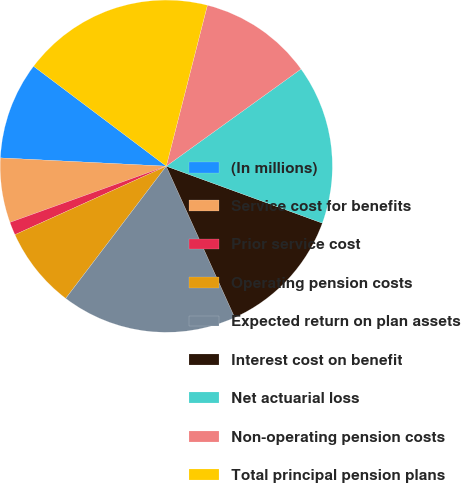Convert chart to OTSL. <chart><loc_0><loc_0><loc_500><loc_500><pie_chart><fcel>(In millions)<fcel>Service cost for benefits<fcel>Prior service cost<fcel>Operating pension costs<fcel>Expected return on plan assets<fcel>Interest cost on benefit<fcel>Net actuarial loss<fcel>Non-operating pension costs<fcel>Total principal pension plans<nl><fcel>9.48%<fcel>6.29%<fcel>1.27%<fcel>7.89%<fcel>17.11%<fcel>12.67%<fcel>15.51%<fcel>11.08%<fcel>18.71%<nl></chart> 